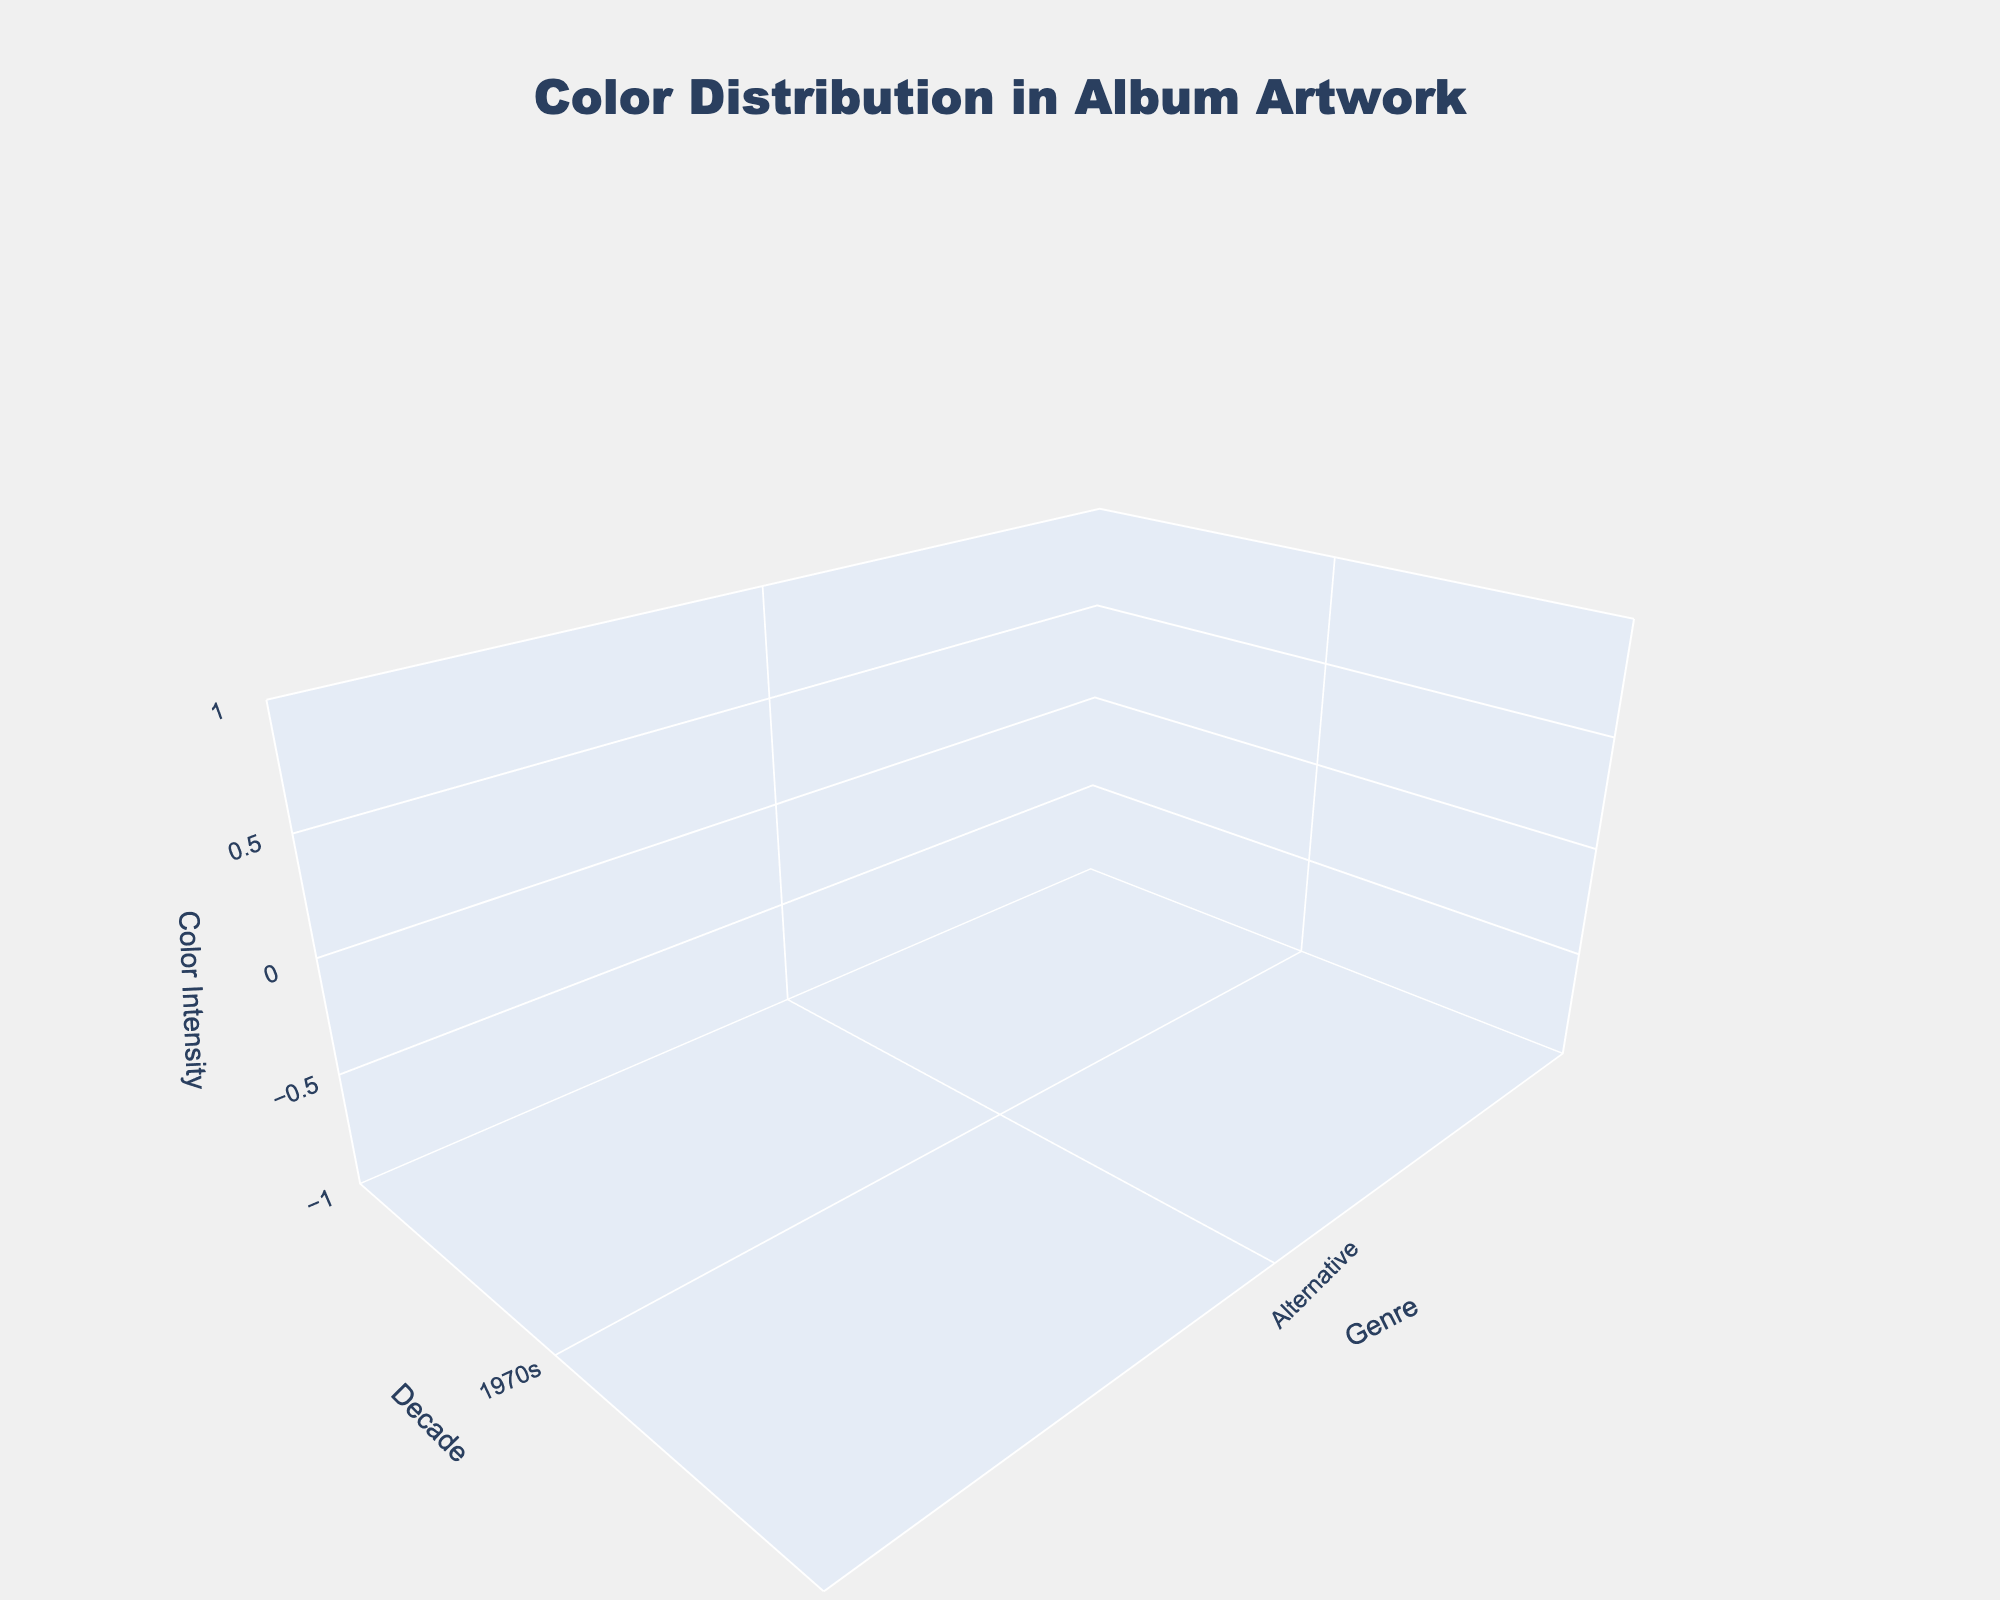what is the title of the plot? The title of the plot is usually located at the top and describes the main subject of the visualization. In this plot, the title indicates what the chart is all about.
Answer: Color Distribution in Album Artwork Which decade has the highest red intensity for Rock genre? Look at the section corresponding to the 'Rock' genre along the horizontal axis and find the decade with the highest elevation in red color intensity.
Answer: 1980s In the 2010s, which genre has the lowest blue intensity? Observe the blue surface in the 2010s section. Compare the heights of the blue surfaces for all genres in that decade.
Answer: Alternative What is the average green intensity for EDM across all decades? Identify the green intensity levels for EDM across all applicable decades and calculate their average. For EDM in 2010s, green intensity is 80. Average = 80.
Answer: 80 How does the blue intensity in the 2000s compare between Hip Hop and Indie? Look at the blue intensity for both 'Hip Hop' and 'Indie' genres in the 2000s and compare their heights.
Answer: Hip Hop > Indie Which genre in the 1970s has the highest overall color intensity? Evaluate the highest elevation of combined red, green, and blue intensities for each genre in the 1970s.
Answer: Disco In the 2020s, which genre has the highest green intensity? Check the green surface's height for each genre in the 2020s, and identify which one has the highest elevation.
Answer: Synthwave How many genres are visualized in each decade? Count the number of different genres presented for each decade along the horizontal axis.
Answer: 3 Compare the red intensities of Grunge in the 1990s and Emo in the 2000s. Which one is higher? Locate the red intensities for 'Grunge' in the 1990s and 'Emo' in the 2000s and compare their heights.
Answer: Grunge > Emo What is the general trend of blue intensity for Hip Hop genre from the 1980s to the 2020s? Observe the pattern of blue intensity for Hip Hop genre across the 1980s, 2000s, and 2010s in sequence.
Answer: Decreases 